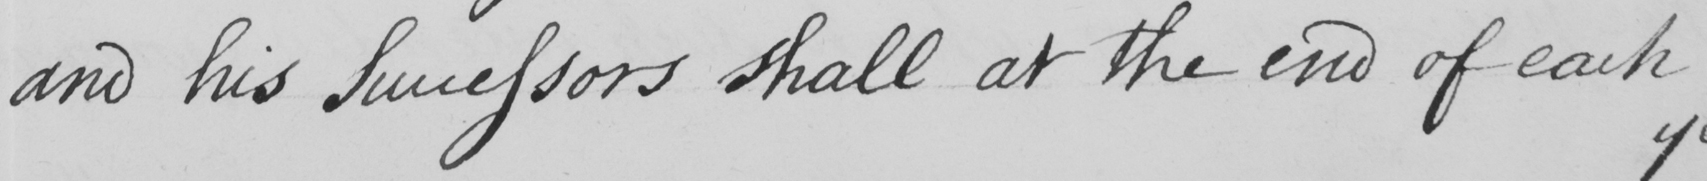What text is written in this handwritten line? and his Successors shall at the end of each 